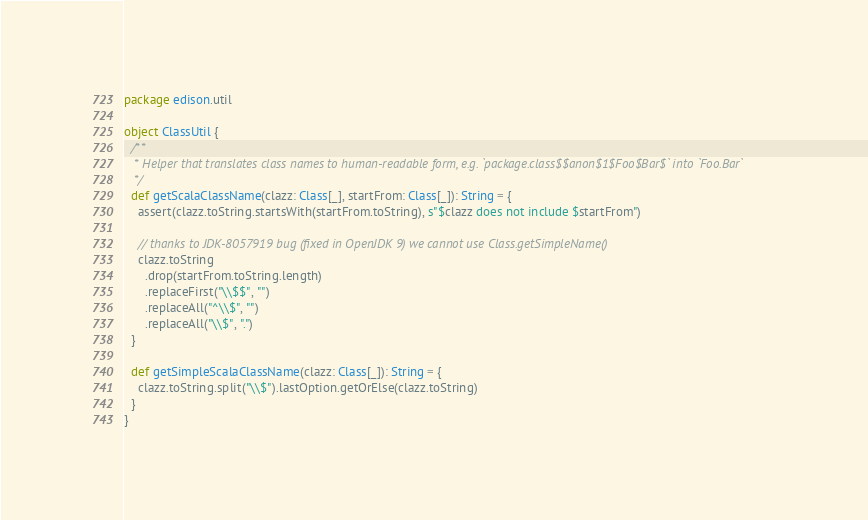<code> <loc_0><loc_0><loc_500><loc_500><_Scala_>package edison.util

object ClassUtil {
  /**
   * Helper that translates class names to human-readable form, e.g. `package.class$$anon$1$Foo$Bar$` into `Foo.Bar`
   */
  def getScalaClassName(clazz: Class[_], startFrom: Class[_]): String = {
    assert(clazz.toString.startsWith(startFrom.toString), s"$clazz does not include $startFrom")

    // thanks to JDK-8057919 bug (fixed in OpenJDK 9) we cannot use Class.getSimpleName()
    clazz.toString
      .drop(startFrom.toString.length)
      .replaceFirst("\\$$", "")
      .replaceAll("^\\$", "")
      .replaceAll("\\$", ".")
  }

  def getSimpleScalaClassName(clazz: Class[_]): String = {
    clazz.toString.split("\\$").lastOption.getOrElse(clazz.toString)
  }
}
</code> 